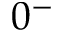Convert formula to latex. <formula><loc_0><loc_0><loc_500><loc_500>0 ^ { - }</formula> 